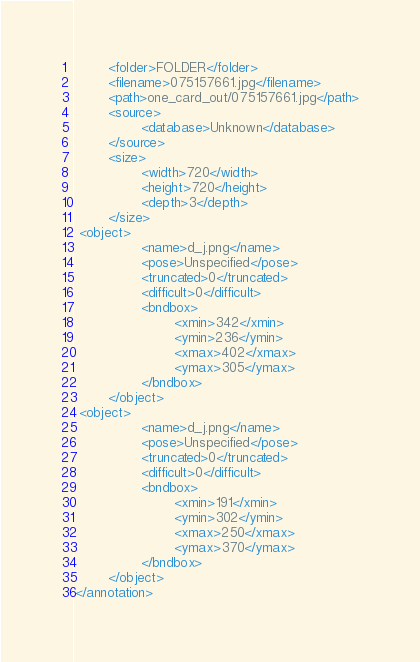<code> <loc_0><loc_0><loc_500><loc_500><_XML_>        <folder>FOLDER</folder>
        <filename>075157661.jpg</filename>
        <path>one_card_out/075157661.jpg</path>
        <source>
                <database>Unknown</database>
        </source>
        <size>
                <width>720</width>
                <height>720</height>
                <depth>3</depth>
        </size>
 <object>
                <name>d_j.png</name>
                <pose>Unspecified</pose>
                <truncated>0</truncated>
                <difficult>0</difficult>
                <bndbox>
                        <xmin>342</xmin>
                        <ymin>236</ymin>
                        <xmax>402</xmax>
                        <ymax>305</ymax>
                </bndbox>
        </object>
 <object>
                <name>d_j.png</name>
                <pose>Unspecified</pose>
                <truncated>0</truncated>
                <difficult>0</difficult>
                <bndbox>
                        <xmin>191</xmin>
                        <ymin>302</ymin>
                        <xmax>250</xmax>
                        <ymax>370</ymax>
                </bndbox>
        </object>
</annotation>        
</code> 